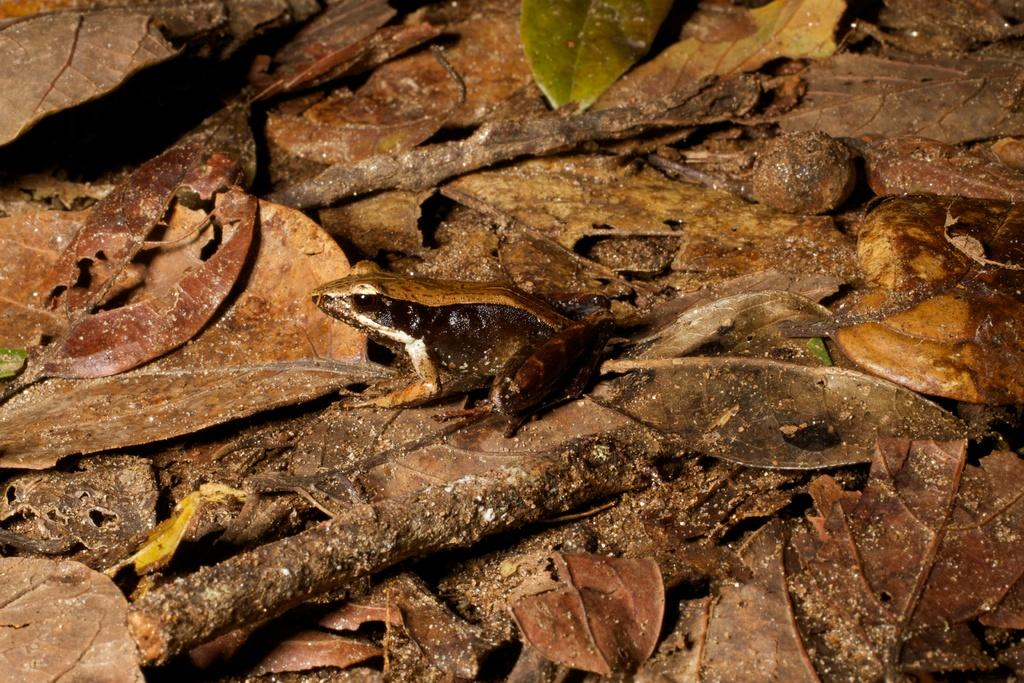What type of vegetation can be seen in the image? There are dried leaves and branches in the image. Can you describe the condition of the vegetation? The leaves appear to be dried, and the branches are likely from a tree or plant. What type of space exploration is depicted in the image? There is no depiction of space exploration in the image; it features dried leaves and branches. 